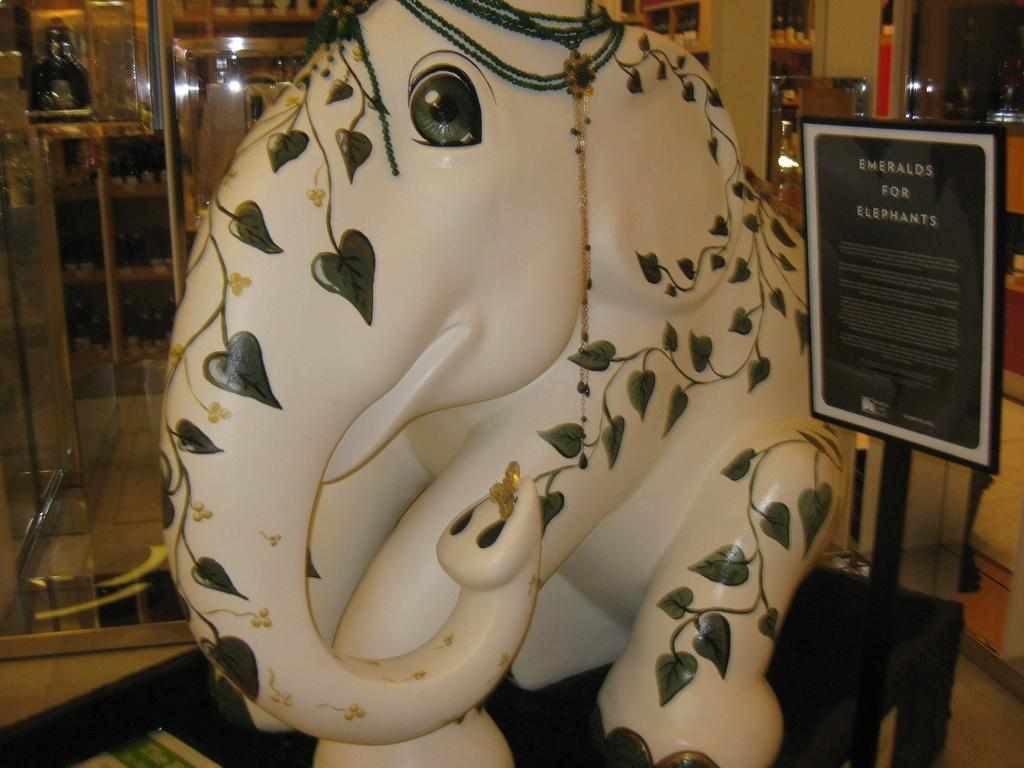What is the main subject of the image? There is a statue of an elephant in the image. What else can be seen near the statue? There is a photo frame with text beside the statue. Is there any architectural feature visible in the image? Yes, there is a glass door behind the elephant statue. What type of hammer can be seen in the image? There is no hammer present in the image. How many fingers are visible in the image? There are no fingers visible in the image. 